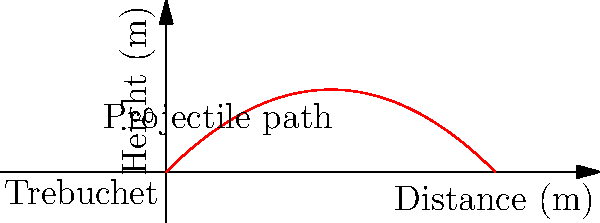In a siege of a fortress during the early Islamic conquests, a trebuchet launches a projectile with an initial velocity of 50 m/s at an angle of 45 degrees. Assuming no air resistance, what is the maximum height reached by the projectile? To find the maximum height reached by the projectile, we can follow these steps:

1) The vertical component of the initial velocity is given by:
   $v_{0y} = v_0 \sin(\theta) = 50 \sin(45°) = 50 \cdot \frac{\sqrt{2}}{2} \approx 35.36$ m/s

2) The time to reach the maximum height is when the vertical velocity becomes zero:
   $v_y = v_{0y} - gt = 0$
   $t = \frac{v_{0y}}{g} = \frac{35.36}{9.8} \approx 3.61$ seconds

3) The maximum height can be calculated using the equation:
   $h_{max} = v_{0y}t - \frac{1}{2}gt^2$

4) Substituting the values:
   $h_{max} = 35.36 \cdot 3.61 - \frac{1}{2} \cdot 9.8 \cdot 3.61^2$
   $h_{max} = 127.65 - 63.82 = 63.83$ meters

Therefore, the maximum height reached by the projectile is approximately 63.83 meters.
Answer: 63.83 meters 